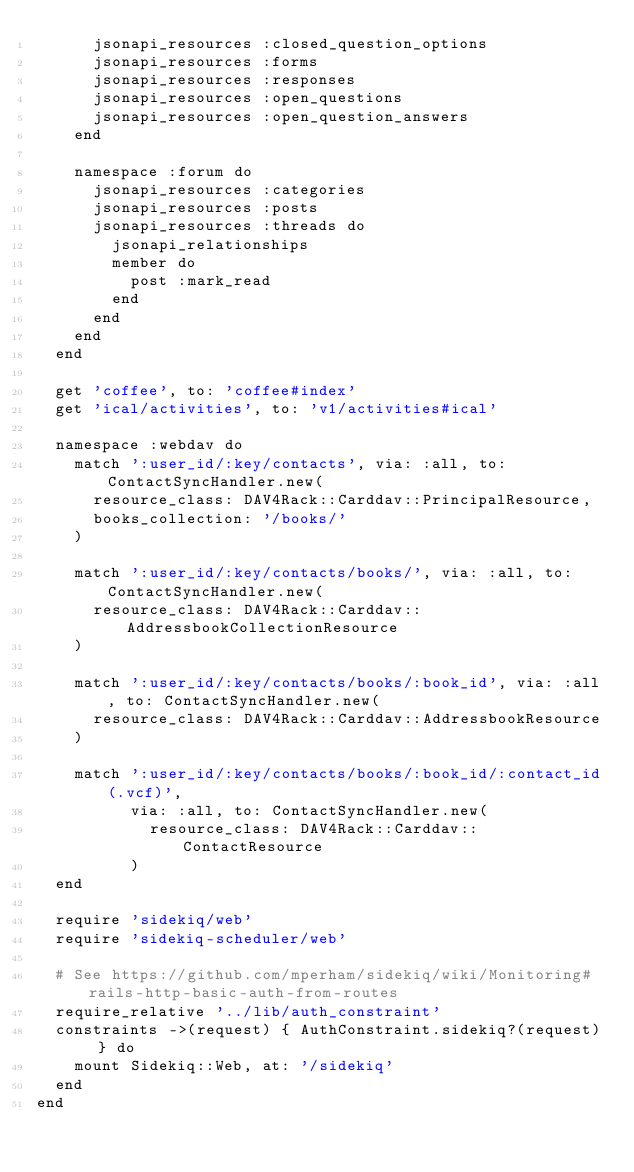Convert code to text. <code><loc_0><loc_0><loc_500><loc_500><_Ruby_>      jsonapi_resources :closed_question_options
      jsonapi_resources :forms
      jsonapi_resources :responses
      jsonapi_resources :open_questions
      jsonapi_resources :open_question_answers
    end

    namespace :forum do
      jsonapi_resources :categories
      jsonapi_resources :posts
      jsonapi_resources :threads do
        jsonapi_relationships
        member do
          post :mark_read
        end
      end
    end
  end

  get 'coffee', to: 'coffee#index'
  get 'ical/activities', to: 'v1/activities#ical'

  namespace :webdav do
    match ':user_id/:key/contacts', via: :all, to: ContactSyncHandler.new(
      resource_class: DAV4Rack::Carddav::PrincipalResource,
      books_collection: '/books/'
    )

    match ':user_id/:key/contacts/books/', via: :all, to: ContactSyncHandler.new(
      resource_class: DAV4Rack::Carddav::AddressbookCollectionResource
    )

    match ':user_id/:key/contacts/books/:book_id', via: :all, to: ContactSyncHandler.new(
      resource_class: DAV4Rack::Carddav::AddressbookResource
    )

    match ':user_id/:key/contacts/books/:book_id/:contact_id(.vcf)',
          via: :all, to: ContactSyncHandler.new(
            resource_class: DAV4Rack::Carddav::ContactResource
          )
  end

  require 'sidekiq/web'
  require 'sidekiq-scheduler/web'

  # See https://github.com/mperham/sidekiq/wiki/Monitoring#rails-http-basic-auth-from-routes
  require_relative '../lib/auth_constraint'
  constraints ->(request) { AuthConstraint.sidekiq?(request) } do
    mount Sidekiq::Web, at: '/sidekiq'
  end
end
</code> 